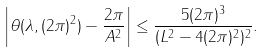Convert formula to latex. <formula><loc_0><loc_0><loc_500><loc_500>\left | \theta ( \lambda , ( 2 \pi ) ^ { 2 } ) - \frac { 2 \pi } { A ^ { 2 } } \right | \leq \frac { 5 ( 2 \pi ) ^ { 3 } } { ( L ^ { 2 } - 4 ( 2 \pi ) ^ { 2 } ) ^ { 2 } } .</formula> 